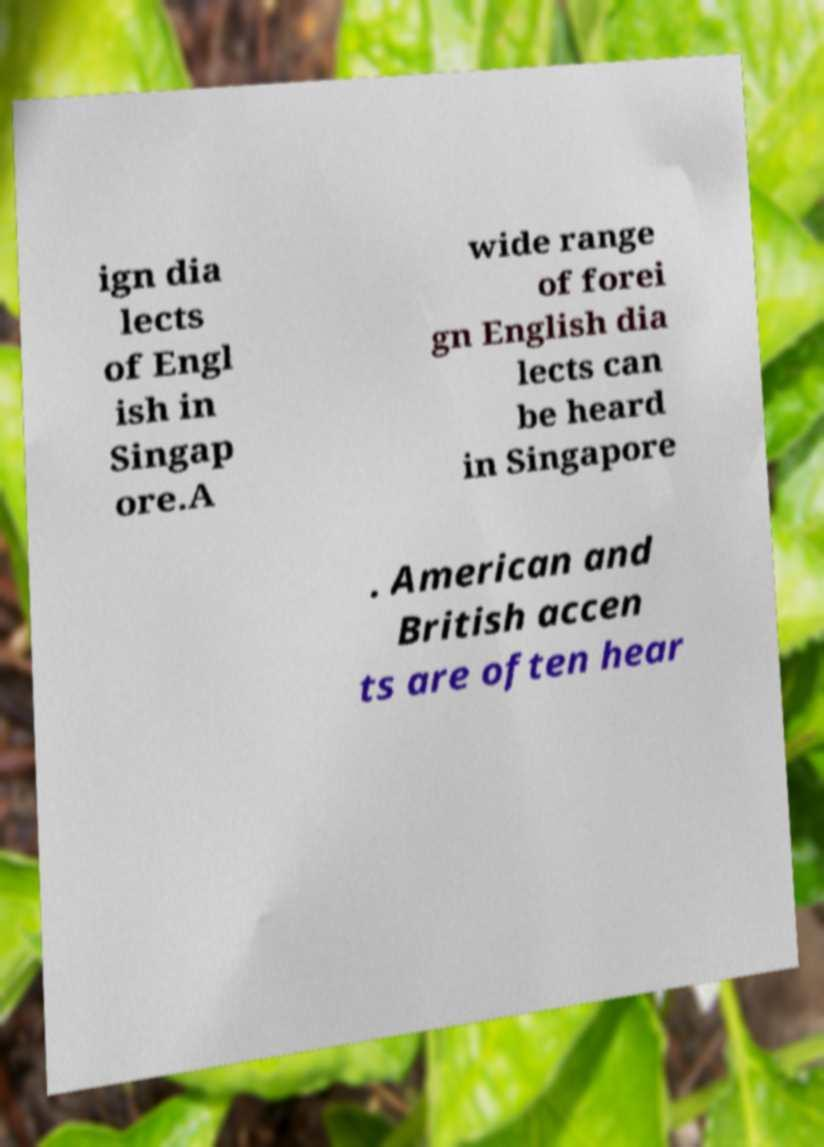Can you accurately transcribe the text from the provided image for me? ign dia lects of Engl ish in Singap ore.A wide range of forei gn English dia lects can be heard in Singapore . American and British accen ts are often hear 